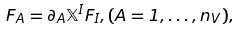<formula> <loc_0><loc_0><loc_500><loc_500>F _ { A } = \partial _ { A } { \mathbb { X } } ^ { I } F _ { I } , ( A = 1 , \dots , n _ { V } ) ,</formula> 